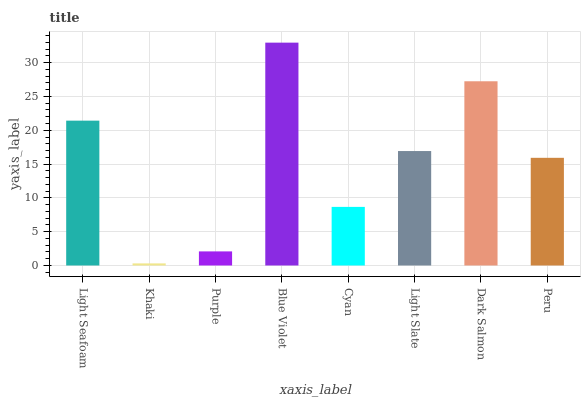Is Khaki the minimum?
Answer yes or no. Yes. Is Blue Violet the maximum?
Answer yes or no. Yes. Is Purple the minimum?
Answer yes or no. No. Is Purple the maximum?
Answer yes or no. No. Is Purple greater than Khaki?
Answer yes or no. Yes. Is Khaki less than Purple?
Answer yes or no. Yes. Is Khaki greater than Purple?
Answer yes or no. No. Is Purple less than Khaki?
Answer yes or no. No. Is Light Slate the high median?
Answer yes or no. Yes. Is Peru the low median?
Answer yes or no. Yes. Is Dark Salmon the high median?
Answer yes or no. No. Is Light Slate the low median?
Answer yes or no. No. 